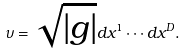<formula> <loc_0><loc_0><loc_500><loc_500>\upsilon = \sqrt { | g | } d x ^ { 1 } \cdots d x ^ { D } .</formula> 